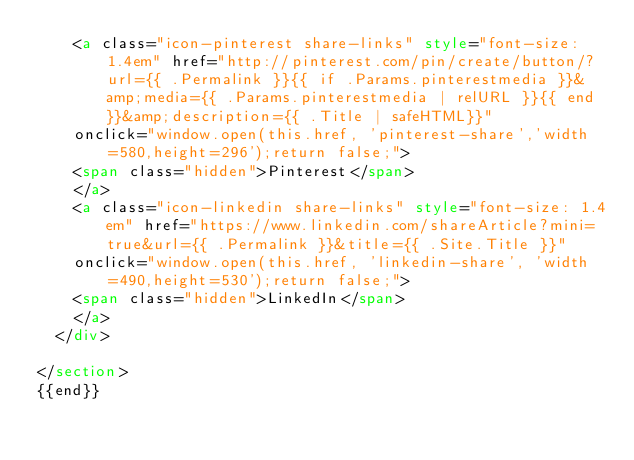<code> <loc_0><loc_0><loc_500><loc_500><_HTML_>    <a class="icon-pinterest share-links" style="font-size: 1.4em" href="http://pinterest.com/pin/create/button/?url={{ .Permalink }}{{ if .Params.pinterestmedia }}&amp;media={{ .Params.pinterestmedia | relURL }}{{ end }}&amp;description={{ .Title | safeHTML}}"
    onclick="window.open(this.href, 'pinterest-share','width=580,height=296');return false;">
    <span class="hidden">Pinterest</span>
    </a>
    <a class="icon-linkedin share-links" style="font-size: 1.4em" href="https://www.linkedin.com/shareArticle?mini=true&url={{ .Permalink }}&title={{ .Site.Title }}"
    onclick="window.open(this.href, 'linkedin-share', 'width=490,height=530');return false;">
    <span class="hidden">LinkedIn</span>
    </a>
  </div>

</section>
{{end}}
</code> 